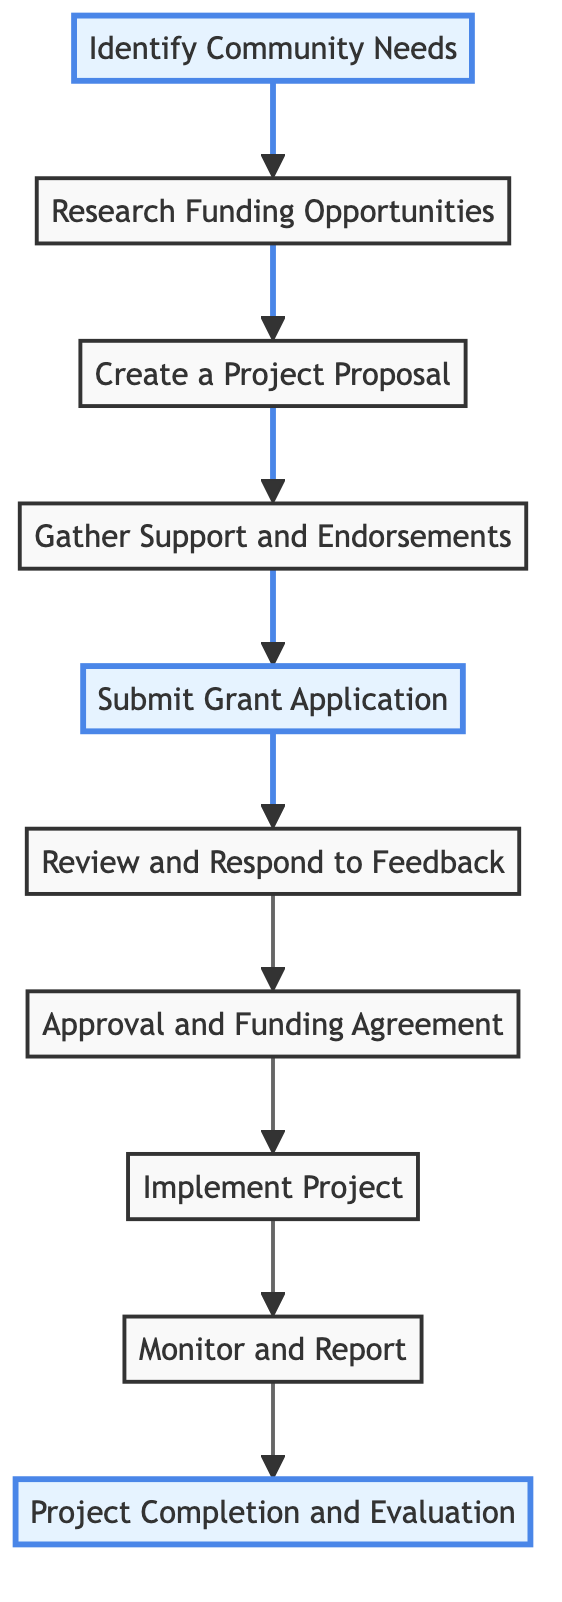What is the first step in the process? The first step, according to the flow chart, is "Identify Community Needs." This is indicated as the starting point of the flow at the top of the diagram.
Answer: Identify Community Needs How many total steps are there in this community funding process? By counting the nodes in the flow chart, there are a total of 10 distinct steps listed, from the start of the process to the end.
Answer: 10 What step comes after "Submit Grant Application"? The flow clearly shows that the step following "Submit Grant Application" is "Review and Respond to Feedback." This can be traced directly from the arrows in the diagram.
Answer: Review and Respond to Feedback Which step involves obtaining letters of support? The diagram specifies that "Gather Support and Endorsements" is the step in which letters of support are obtained from stakeholders, as highlighted in the description connected to this node.
Answer: Gather Support and Endorsements What is the final step of the process? At the bottom of the flow chart, "Project Completion and Evaluation" is indicated as the last step in the process, which encapsulates the final actions and assessments of the project.
Answer: Project Completion and Evaluation Which step is emphasized in blue? The flow chart visually emphasizes "Identify Community Needs," "Submit Grant Application," and "Project Completion and Evaluation" using a blue highlight, indicating their importance in the process.
Answer: Identify Community Needs, Submit Grant Application, Project Completion and Evaluation What is required before submitting the grant application? The process outlines that obtaining "Gather Support and Endorsements" is a prerequisite step that must be completed before the grant application can be submitted.
Answer: Gather Support and Endorsements Explain what happens after obtaining grant approval. Once the grant is approved, the next logical step according to the chart is to review and sign the "Approval and Funding Agreement." This step establishes the terms and conditions for the funding received.
Answer: Review and sign the funding agreement What do you do after you implement the project? After the project is implemented, the flow chart indicates that you must "Monitor and Report" on its progress and submit required reports, ensuring compliance with funding conditions.
Answer: Monitor and Report 